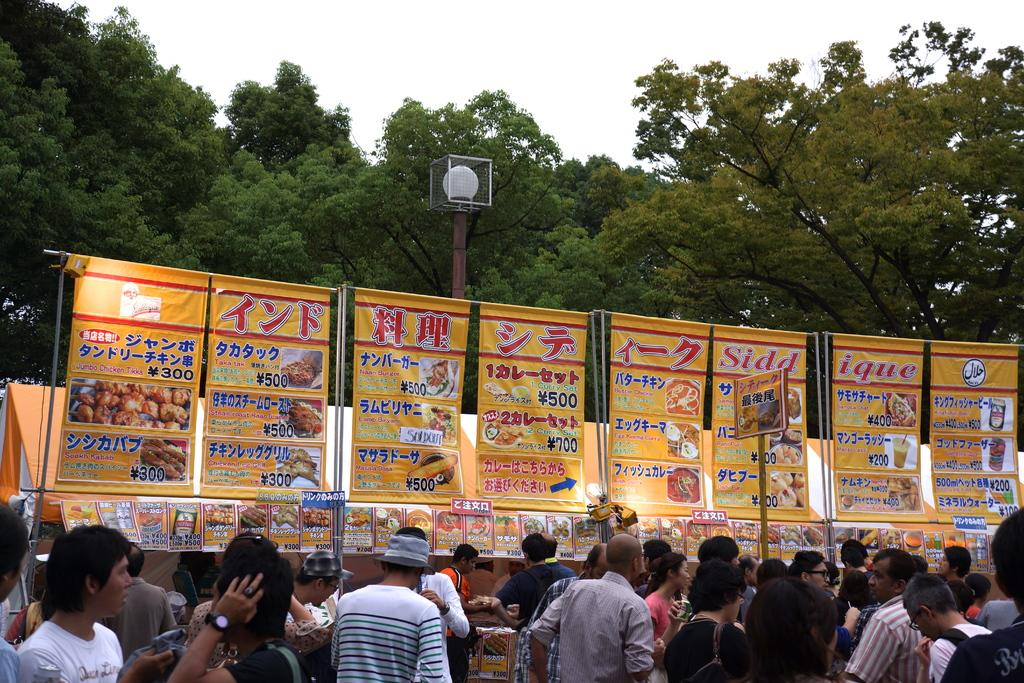Who or what can be seen in the image? There are people in the image. What else is present in the image besides the people? There are posters with text and images, poles, trees, a light, and the sky is visible in the background. What type of cup can be seen catching a bit in the image? There is no cup or bit present in the image. Is there a net visible in the image? No, there is no net visible in the image. 